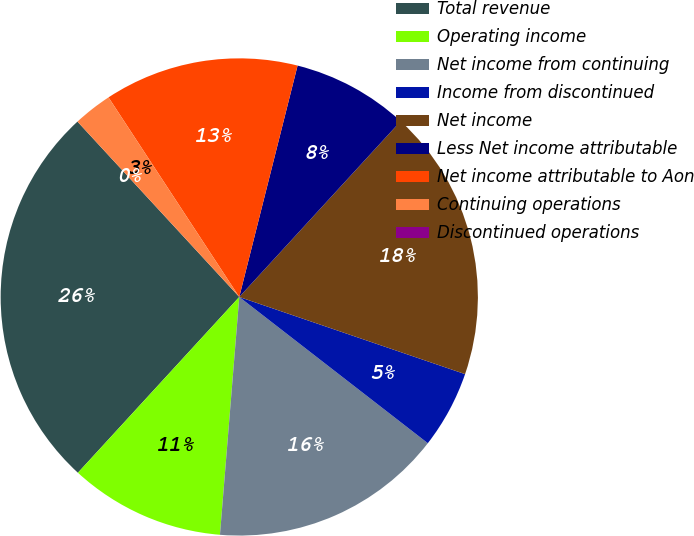<chart> <loc_0><loc_0><loc_500><loc_500><pie_chart><fcel>Total revenue<fcel>Operating income<fcel>Net income from continuing<fcel>Income from discontinued<fcel>Net income<fcel>Less Net income attributable<fcel>Net income attributable to Aon<fcel>Continuing operations<fcel>Discontinued operations<nl><fcel>26.32%<fcel>10.53%<fcel>15.79%<fcel>5.26%<fcel>18.42%<fcel>7.89%<fcel>13.16%<fcel>2.63%<fcel>0.0%<nl></chart> 